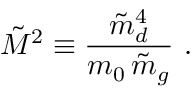<formula> <loc_0><loc_0><loc_500><loc_500>\tilde { M } ^ { 2 } \equiv \frac { \tilde { m } _ { d } ^ { 4 } } { m _ { 0 } \, \tilde { m } _ { g } } \ .</formula> 